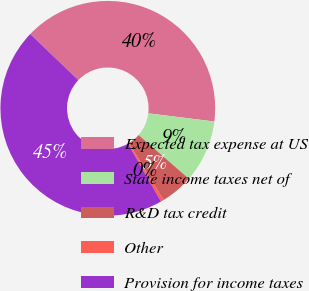<chart> <loc_0><loc_0><loc_500><loc_500><pie_chart><fcel>Expected tax expense at US<fcel>State income taxes net of<fcel>R&D tax credit<fcel>Other<fcel>Provision for income taxes<nl><fcel>39.82%<fcel>9.42%<fcel>4.93%<fcel>0.43%<fcel>45.41%<nl></chart> 